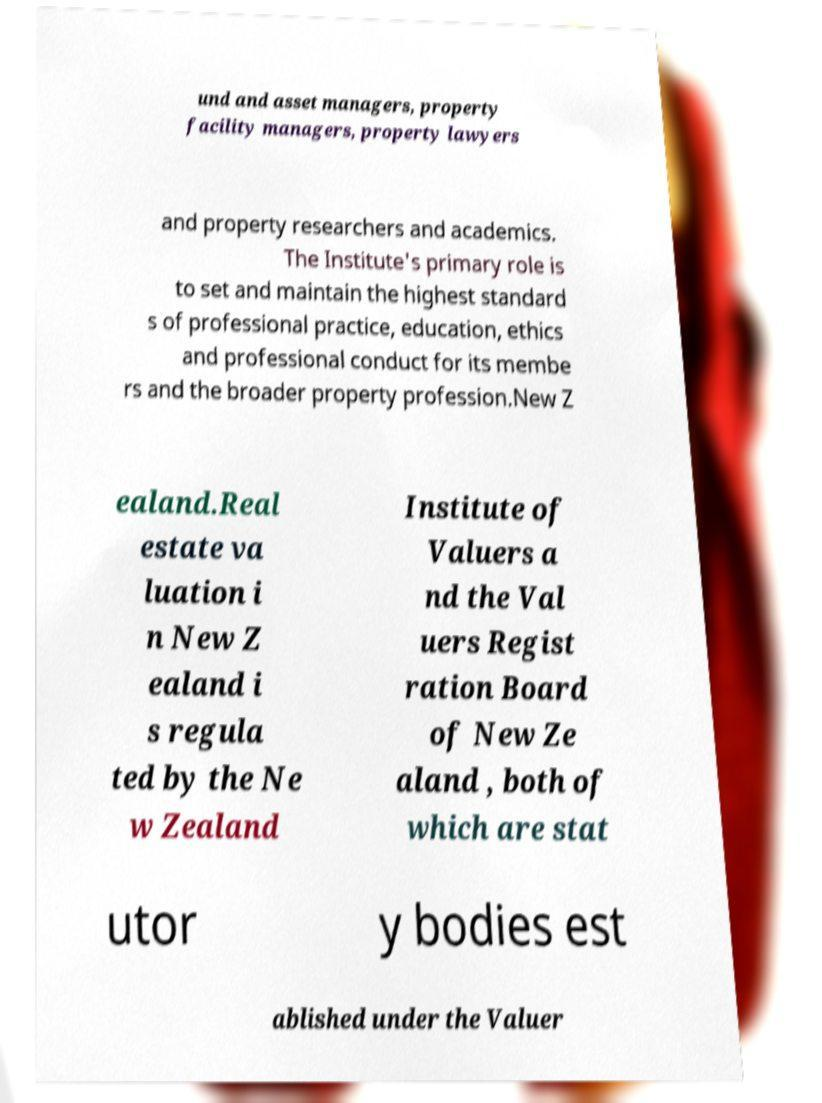Can you accurately transcribe the text from the provided image for me? und and asset managers, property facility managers, property lawyers and property researchers and academics. The Institute's primary role is to set and maintain the highest standard s of professional practice, education, ethics and professional conduct for its membe rs and the broader property profession.New Z ealand.Real estate va luation i n New Z ealand i s regula ted by the Ne w Zealand Institute of Valuers a nd the Val uers Regist ration Board of New Ze aland , both of which are stat utor y bodies est ablished under the Valuer 